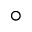<formula> <loc_0><loc_0><loc_500><loc_500>^ { \circ }</formula> 